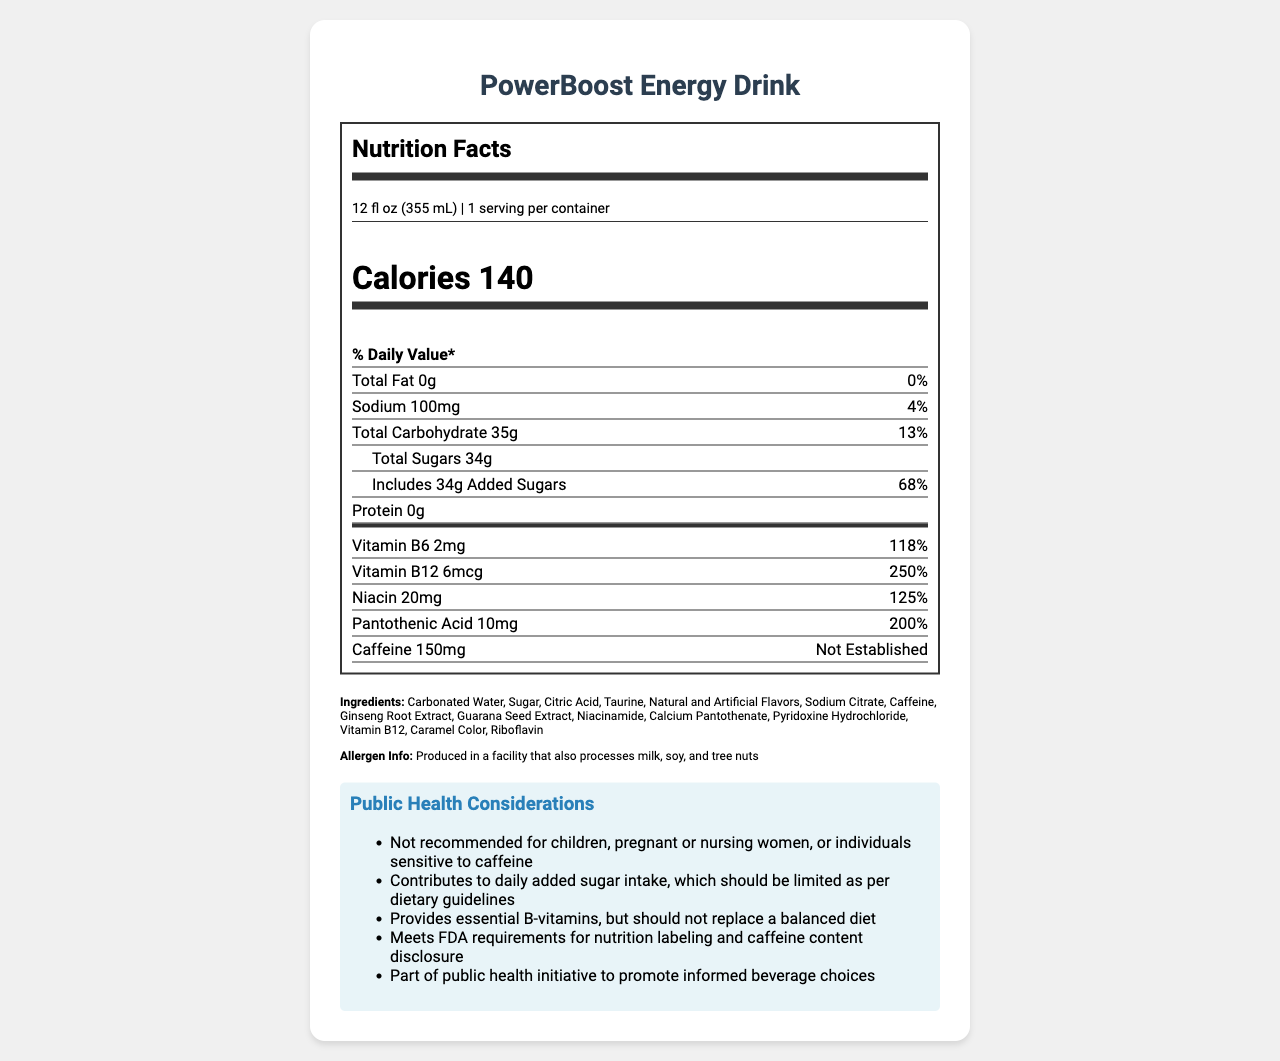what is the serving size of PowerBoost Energy Drink? The serving size is listed at the beginning of the nutrition facts, detailed as 12 fl oz (355 mL).
Answer: 12 fl oz (355 mL) how many calories are in one serving of PowerBoost Energy Drink? The number of calories per serving is specified in the nutrition facts as 140.
Answer: 140 calories what is the total carbohydrate content for one serving? The total carbohydrate content is listed as 35g in the nutrition facts section.
Answer: 35g how much caffeine does one serving of PowerBoost Energy Drink contain? The caffeine content is specified as 150mg under the nutrition facts section.
Answer: 150mg what is the percentage daily value of vitamin B12 in PowerBoost Energy Drink? The document states that the percentage daily value of vitamin B12 is 250%.
Answer: 250% which of the following ingredients is NOT listed in PowerBoost Energy Drink? A. Sodium Citrate B. High Fructose Corn Syrup C. Citric Acid D. Guarana Seed Extract The ingredient list includes Sodium Citrate, Citric Acid, and Guarana Seed Extract but does not mention High Fructose Corn Syrup.
Answer: B. High Fructose Corn Syrup how many grams of added sugars are in one serving? A. 10g B. 20g C. 34g D. 68g The document specifies that there are 34g of added sugars in one serving.
Answer: C. 34g does the PowerBoost Energy Drink contain any fat? The Total Fat is listed as 0g, indicating that there is no fat present in the drink.
Answer: No is PowerBoost Energy Drink recommended for children or pregnant women? The public health considerations clearly state that the drink is not recommended for children, pregnant or nursing women, or individuals sensitive to caffeine due to its high caffeine content.
Answer: No summarize the main public health considerations mentioned in the document for PowerBoost Energy Drink. The document highlights several public health considerations: it advises against consumption by children or pregnant women due to high caffeine levels, notes the high sugar content, states the vitamin fortification should not replace a balanced diet, confirms FDA compliance, and mentions consumer education to promote informed beverage choices.
Answer: Not recommended for children, pregnant or nursing women due to high caffeine content; high sugar content contributing to daily sugar intake; vitamin fortification but not a replacement for a balanced diet; meets FDA regulatory compliance; promotes informed beverage choices. what is the manufacturing location of PowerBoost Energy Drink? The document does not provide any information regarding the manufacturing location. It only mentions the manufacturer, HealthyBoost Beverages Inc., and that distribution is nationwide.
Answer: Cannot be determined 